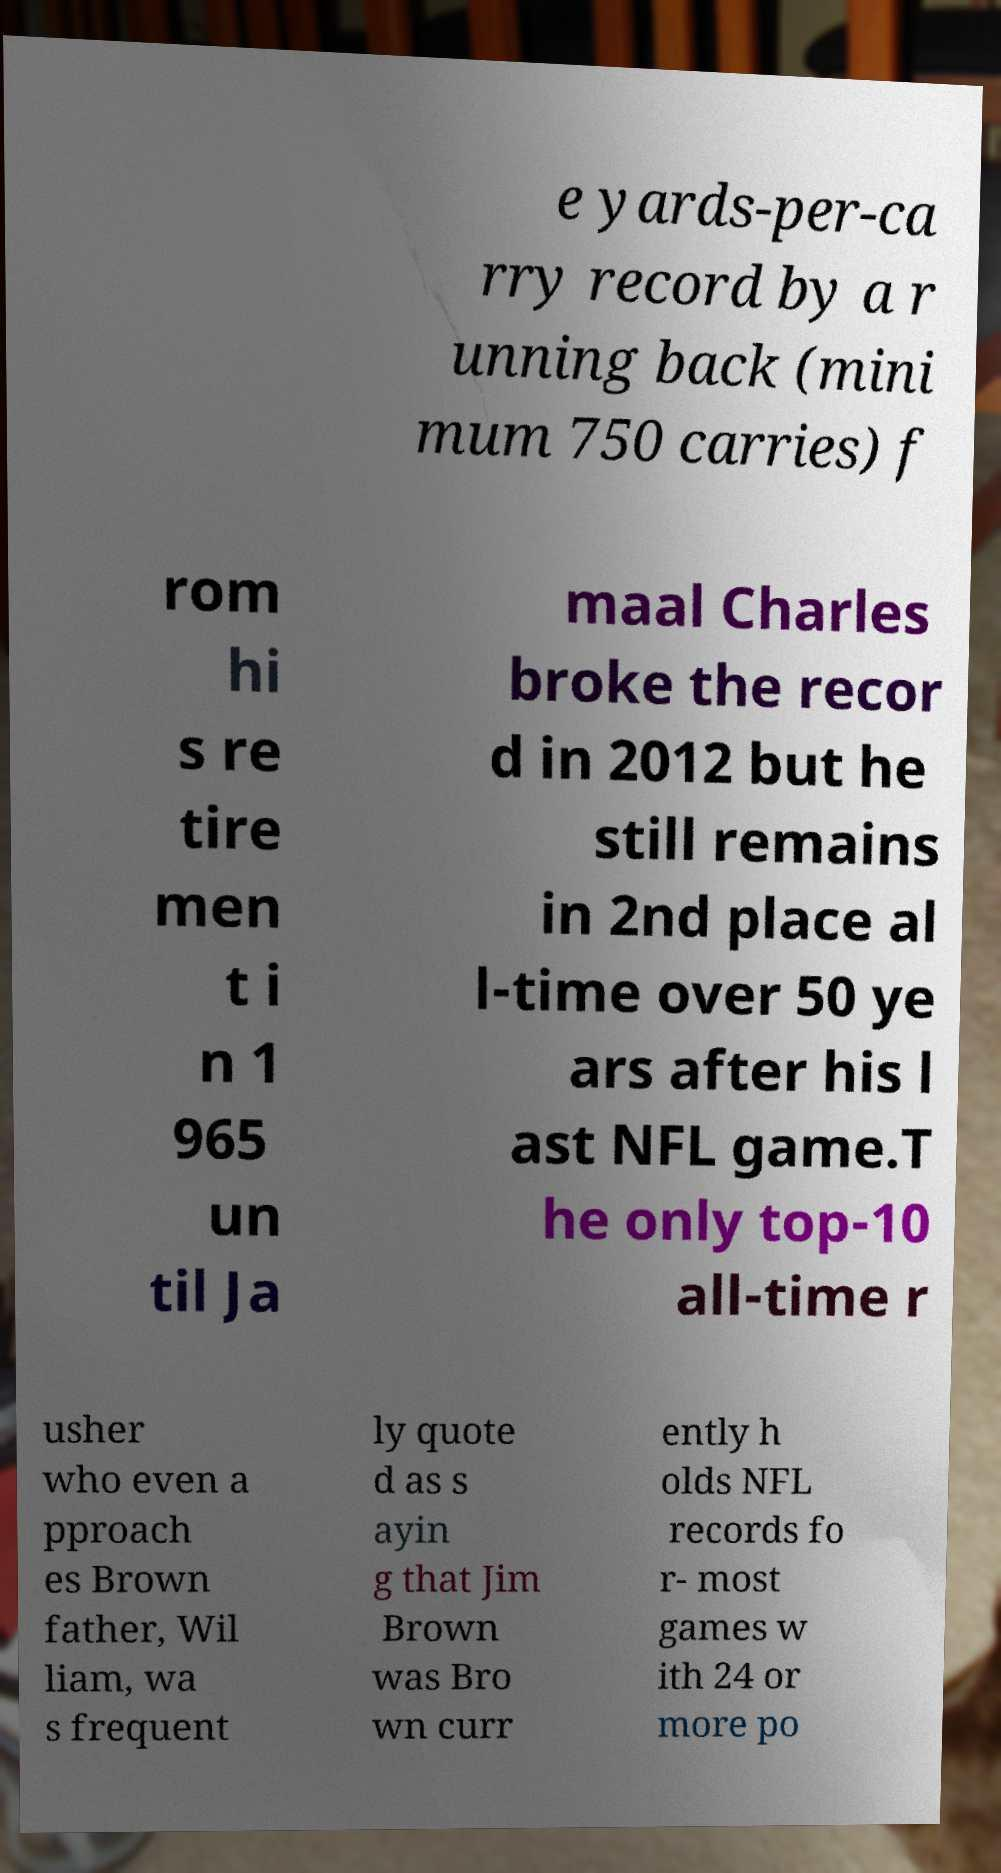Please identify and transcribe the text found in this image. e yards-per-ca rry record by a r unning back (mini mum 750 carries) f rom hi s re tire men t i n 1 965 un til Ja maal Charles broke the recor d in 2012 but he still remains in 2nd place al l-time over 50 ye ars after his l ast NFL game.T he only top-10 all-time r usher who even a pproach es Brown father, Wil liam, wa s frequent ly quote d as s ayin g that Jim Brown was Bro wn curr ently h olds NFL records fo r- most games w ith 24 or more po 